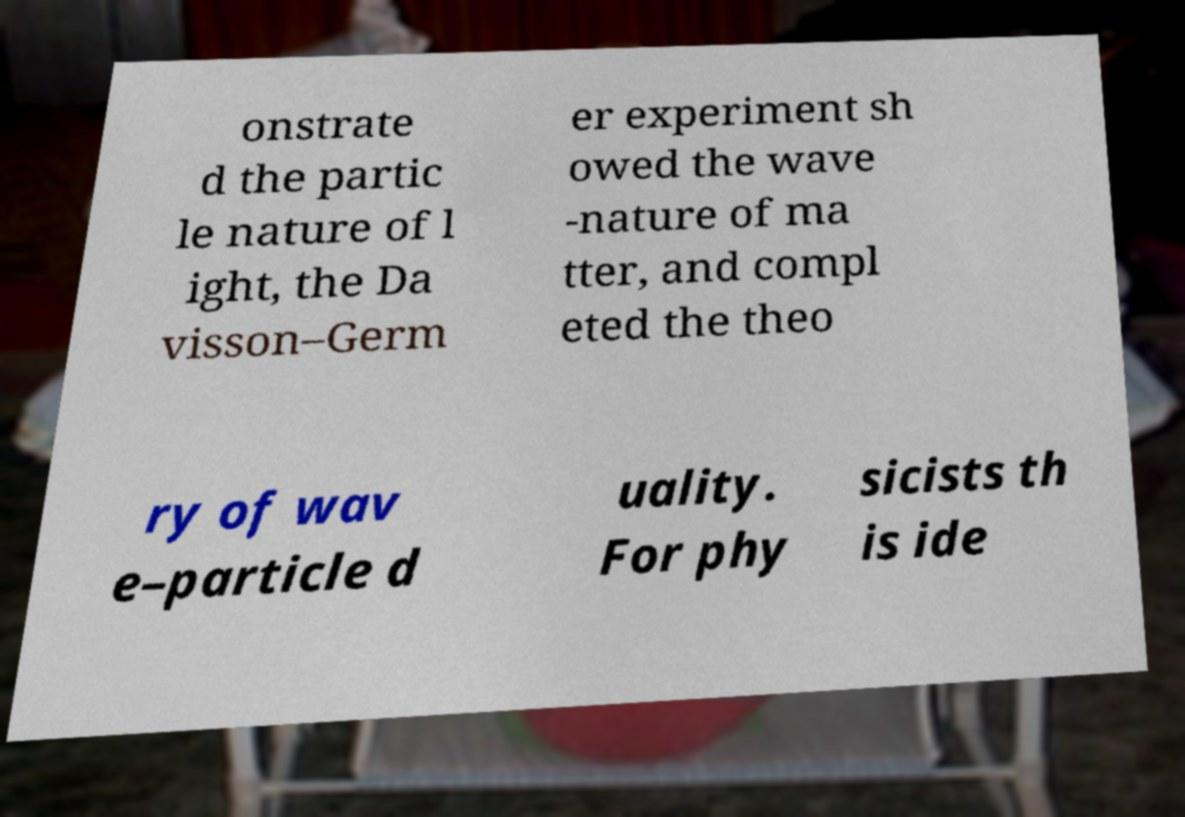Could you assist in decoding the text presented in this image and type it out clearly? onstrate d the partic le nature of l ight, the Da visson–Germ er experiment sh owed the wave -nature of ma tter, and compl eted the theo ry of wav e–particle d uality. For phy sicists th is ide 